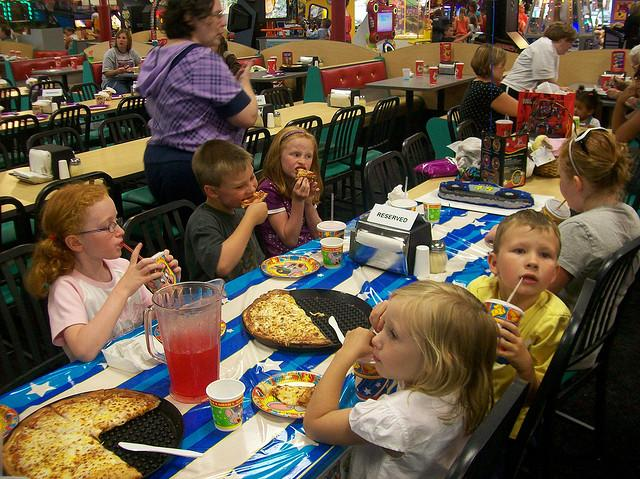What is a likely occasion for all the kids getting together? Please explain your reasoning. birthday party. Given the presents on the table combined with what appears to be a race car-themed birthday cake, this event would most decidedly have to be a child's birthday party. 